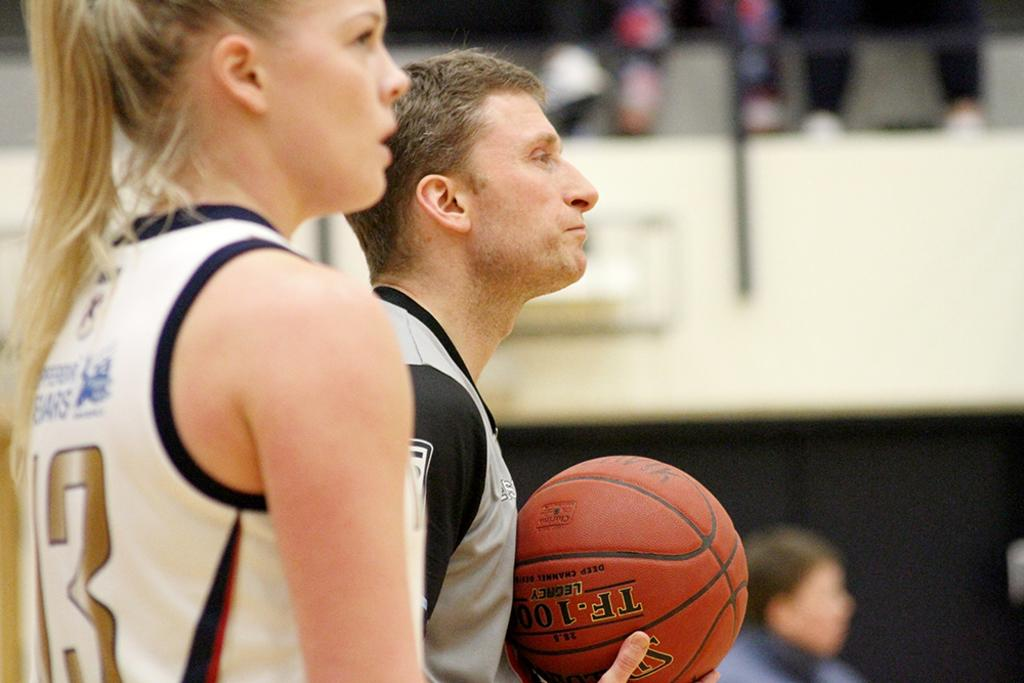<image>
Present a compact description of the photo's key features. A referee who is standing next to a female player holds a TF-100 model basketball. 